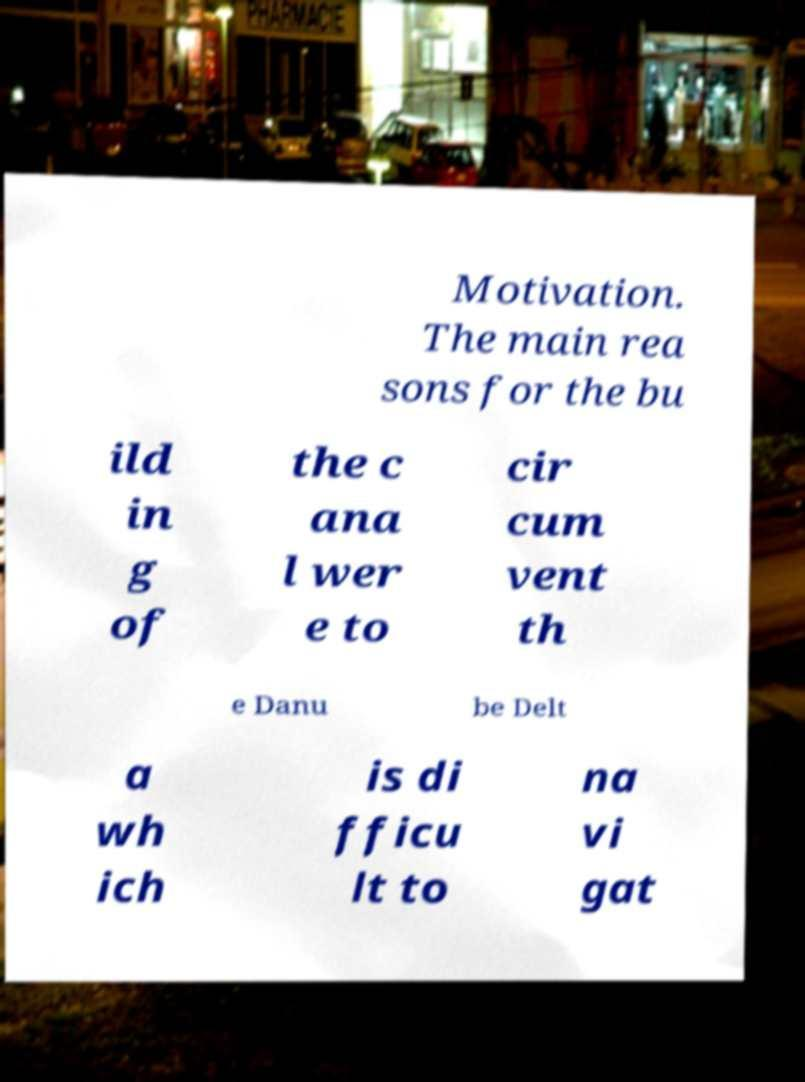Could you assist in decoding the text presented in this image and type it out clearly? Motivation. The main rea sons for the bu ild in g of the c ana l wer e to cir cum vent th e Danu be Delt a wh ich is di fficu lt to na vi gat 